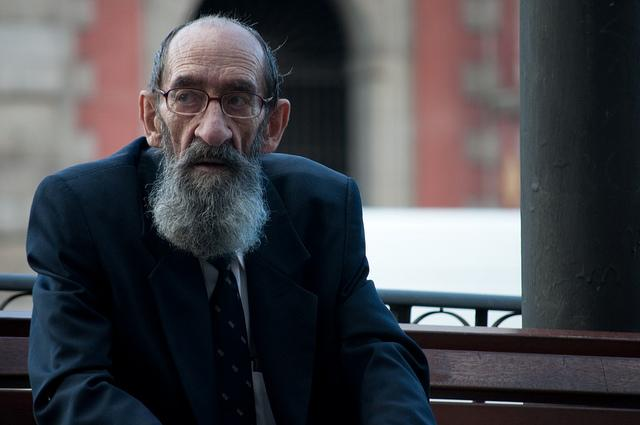What color is the jacket blazer worn by the man with the beard? Please explain your reasoning. blue. The man with the beard is wearing a blazer that is dark blue. 